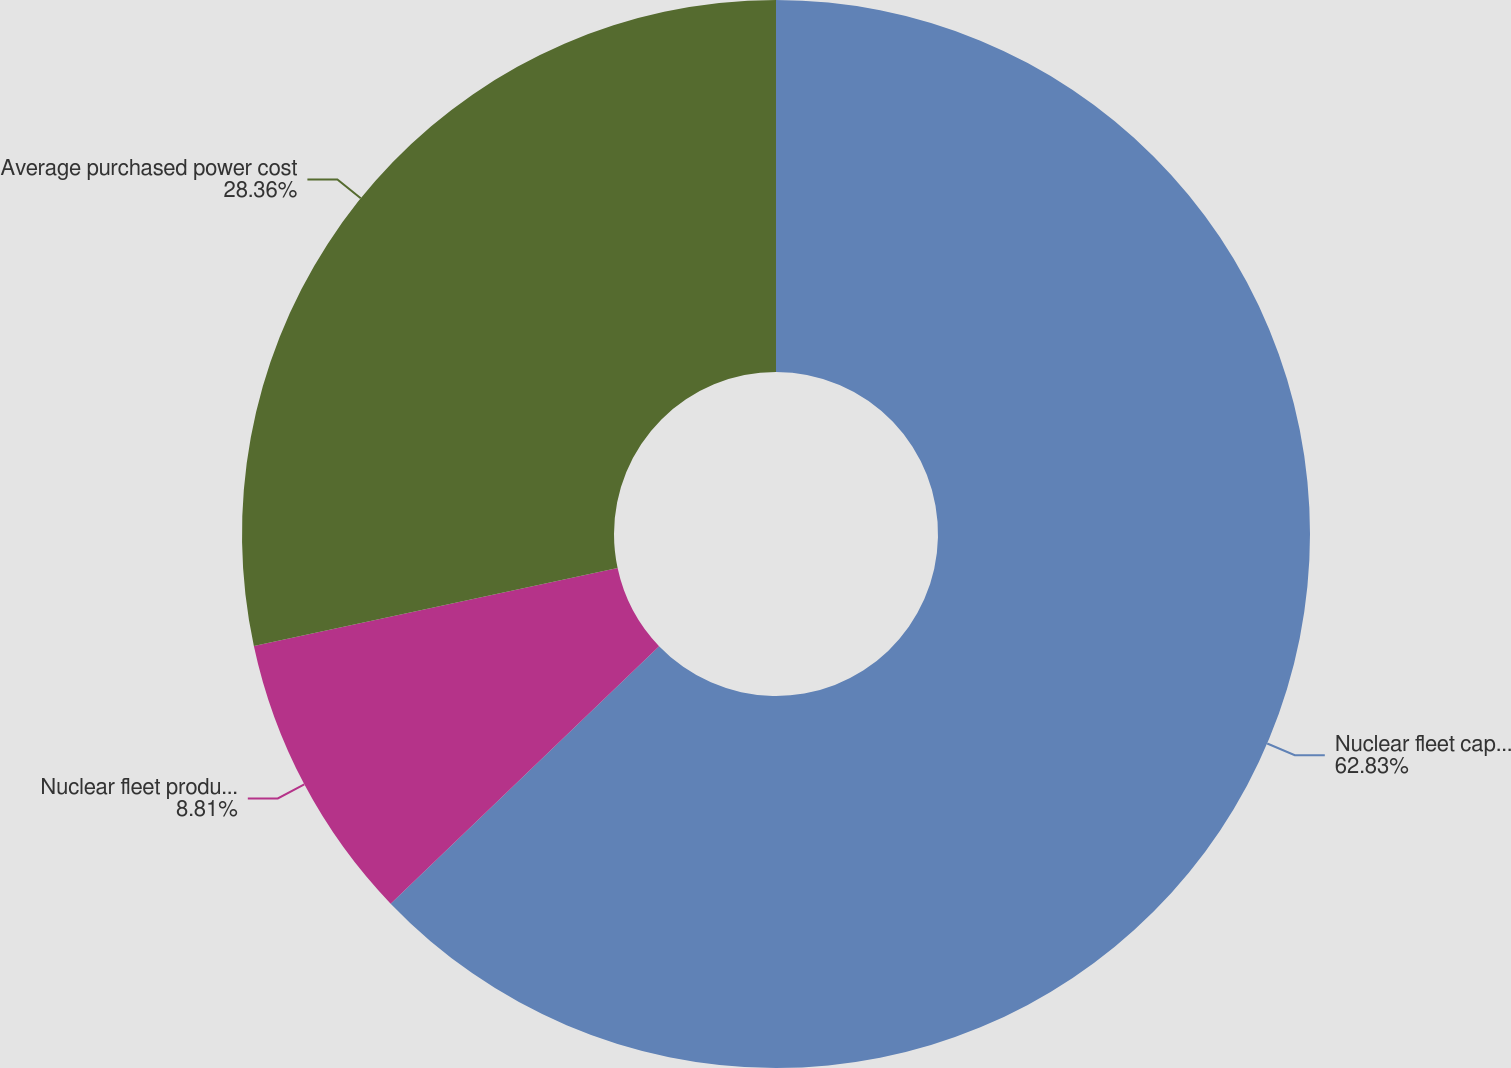Convert chart to OTSL. <chart><loc_0><loc_0><loc_500><loc_500><pie_chart><fcel>Nuclear fleet capacity factor<fcel>Nuclear fleet production cost<fcel>Average purchased power cost<nl><fcel>62.83%<fcel>8.81%<fcel>28.36%<nl></chart> 